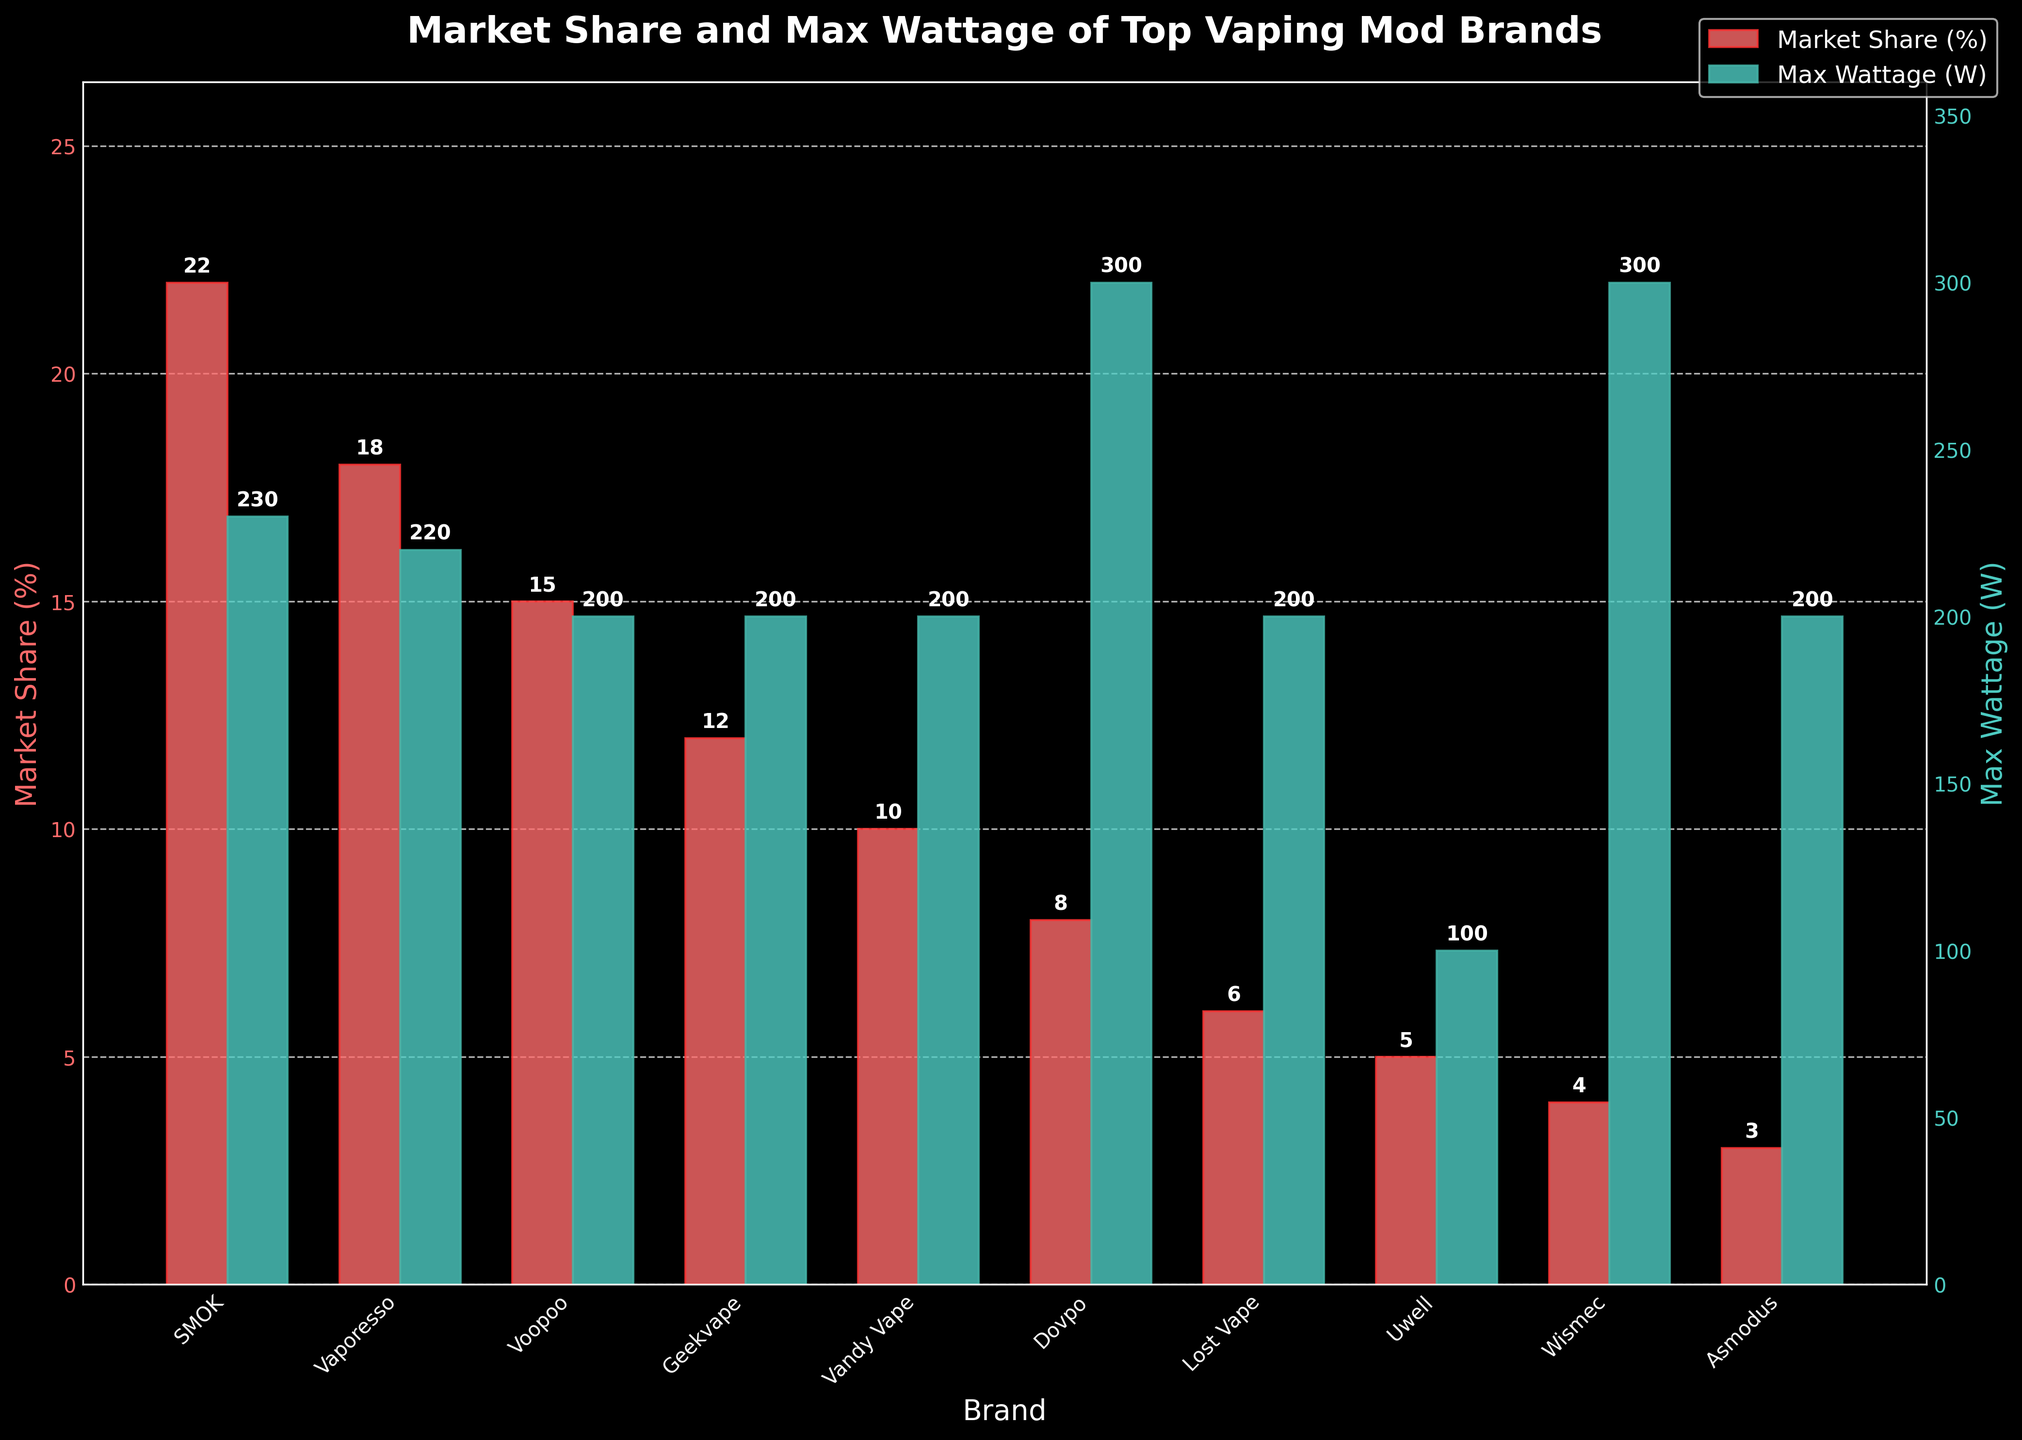Which brand has the highest market share? The highest bar in the red bars, representing market share, is for the SMOK brand.
Answer: SMOK What is the difference in market share between SMOK and Vaporesso? SMOK has a market share of 22%, and Vaporesso has 18%. The difference is 22 - 18.
Answer: 4% Which brand offers the highest max wattage? The highest bar in the green bars, representing max wattage, is for the Dovpo and Wismec brands, which both reach 300W.
Answer: Dovpo and Wismec Which brand has the smallest market share? The smallest bar in the red bars, representing market share, is for the Asmodus brand.
Answer: Asmodus How does Vandy Vape's max wattage compare to that of Uwell? Vandy Vape has a max wattage of 200W, while Uwell has a max wattage of 100W. Vandy Vape's max wattage is double that of Uwell.
Answer: Vandy Vape's wattage is double Uwell's What is the total market share for brands with a max wattage of 200W? The brands with a max wattage of 200W are Voopoo, Geekvape, Vandy Vape, Lost Vape, and Asmodus. Their market shares are 15%, 12%, 10%, 6%, and 3%, respectively. The sum is 15 + 12 + 10 + 6 + 3.
Answer: 46% Which brand has a higher market share: Geekvape or Vandy Vape? Geekvape has a market share of 12%, while Vandy Vape has 10%. Therefore, Geekvape has a higher market share.
Answer: Geekvape Identify the brand with the least max wattage and its corresponding market share. The smallest bar in the green bars, representing max wattage, is for the Uwell brand with 100W. Uwell's market share is 5%.
Answer: Uwell, 5% What is the average max wattage capability for all the brands? The max wattages are 230, 220, 200, 200, 200, 300, 200, 100, 300, and 200. The sum is 2150, and there are 10 brands, so the average is 2150/10.
Answer: 215W Which brand has a similar market share to Voopoo but a significantly different max wattage? Voopoo has a market share of 15%. The brand Wismec has a market share of 4% and a significantly different max wattage of 300W, compared to Voopoo's 200W.
Answer: Wismec 